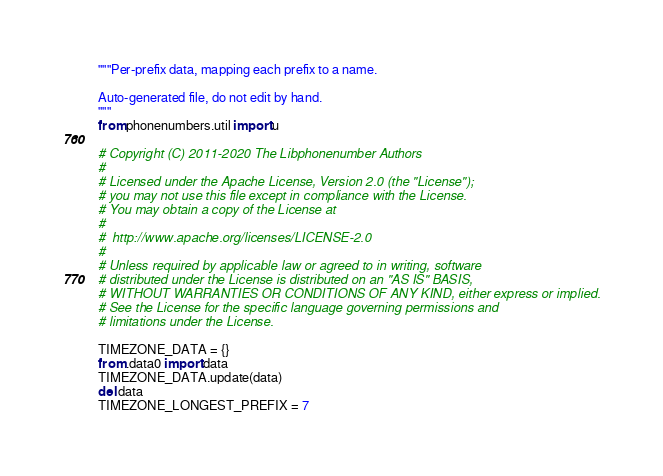<code> <loc_0><loc_0><loc_500><loc_500><_Python_>"""Per-prefix data, mapping each prefix to a name.

Auto-generated file, do not edit by hand.
"""
from phonenumbers.util import u

# Copyright (C) 2011-2020 The Libphonenumber Authors
#
# Licensed under the Apache License, Version 2.0 (the "License");
# you may not use this file except in compliance with the License.
# You may obtain a copy of the License at
#
#  http://www.apache.org/licenses/LICENSE-2.0
#
# Unless required by applicable law or agreed to in writing, software
# distributed under the License is distributed on an "AS IS" BASIS,
# WITHOUT WARRANTIES OR CONDITIONS OF ANY KIND, either express or implied.
# See the License for the specific language governing permissions and
# limitations under the License.

TIMEZONE_DATA = {}
from .data0 import data
TIMEZONE_DATA.update(data)
del data
TIMEZONE_LONGEST_PREFIX = 7
</code> 